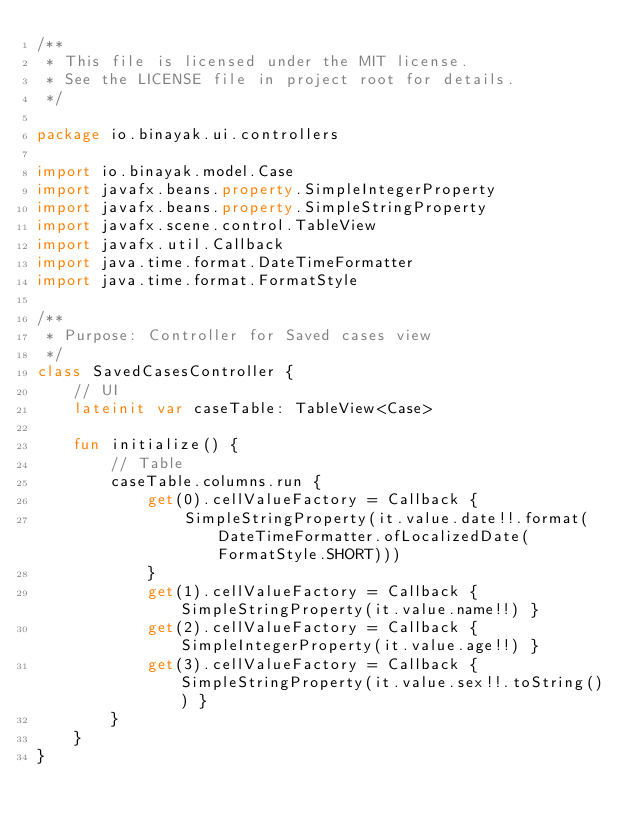Convert code to text. <code><loc_0><loc_0><loc_500><loc_500><_Kotlin_>/**
 * This file is licensed under the MIT license.
 * See the LICENSE file in project root for details.
 */

package io.binayak.ui.controllers

import io.binayak.model.Case
import javafx.beans.property.SimpleIntegerProperty
import javafx.beans.property.SimpleStringProperty
import javafx.scene.control.TableView
import javafx.util.Callback
import java.time.format.DateTimeFormatter
import java.time.format.FormatStyle

/**
 * Purpose: Controller for Saved cases view
 */
class SavedCasesController {
    // UI
    lateinit var caseTable: TableView<Case>

    fun initialize() {
        // Table
        caseTable.columns.run {
            get(0).cellValueFactory = Callback {
                SimpleStringProperty(it.value.date!!.format(DateTimeFormatter.ofLocalizedDate(FormatStyle.SHORT)))
            }
            get(1).cellValueFactory = Callback { SimpleStringProperty(it.value.name!!) }
            get(2).cellValueFactory = Callback { SimpleIntegerProperty(it.value.age!!) }
            get(3).cellValueFactory = Callback { SimpleStringProperty(it.value.sex!!.toString()) }
        }
    }
}</code> 